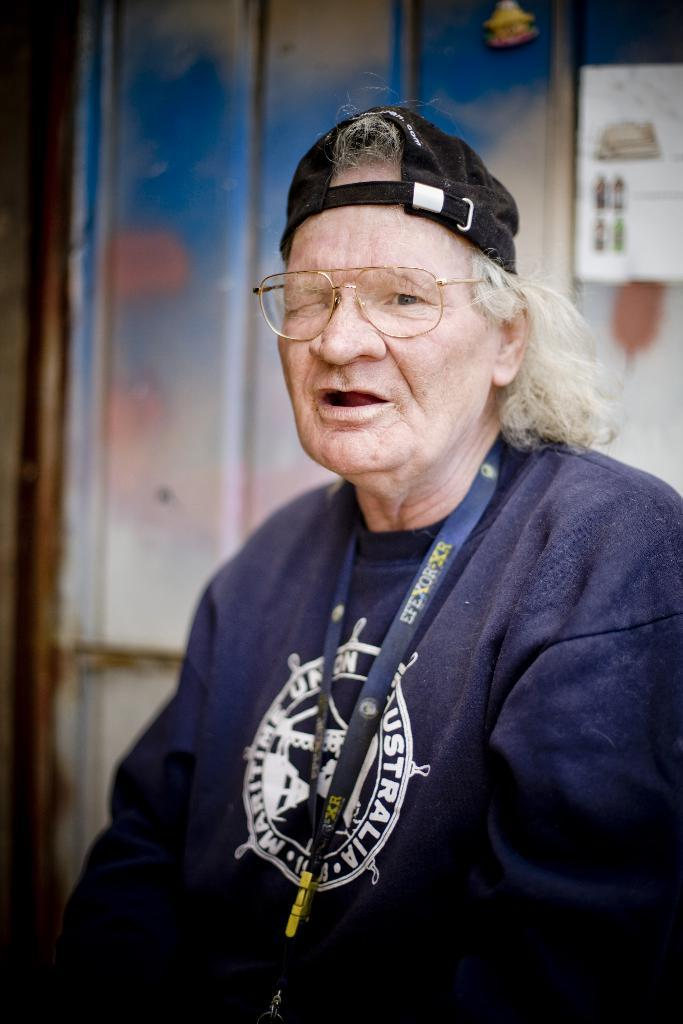Who or what is present in the image? There is a person in the image. What is the person wearing? The person is wearing clothes. Are there any accessories visible on the person? Yes, the person is wearing spectacles. What type of popcorn is being served at the meeting in the image? There is no meeting or popcorn present in the image; it only features a person wearing clothes and spectacles. 